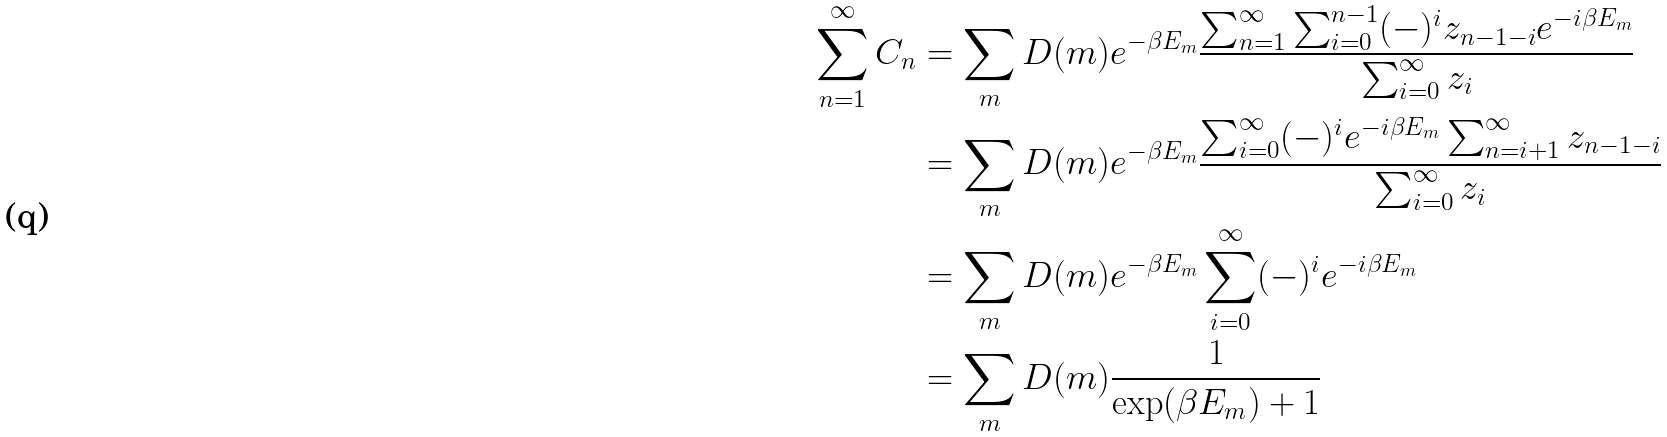Convert formula to latex. <formula><loc_0><loc_0><loc_500><loc_500>\sum _ { n = 1 } ^ { \infty } C _ { n } & = \sum _ { m } D ( m ) e ^ { - \beta E _ { m } } \frac { \sum _ { n = 1 } ^ { \infty } \sum _ { i = 0 } ^ { n - 1 } ( - ) ^ { i } z _ { n - 1 - i } e ^ { - i \beta E _ { m } } } { \sum _ { i = 0 } ^ { \infty } z _ { i } } \\ & = \sum _ { m } D ( m ) e ^ { - \beta E _ { m } } \frac { \sum _ { i = 0 } ^ { \infty } ( - ) ^ { i } e ^ { - i \beta E _ { m } } \sum _ { n = i + 1 } ^ { \infty } z _ { n - 1 - i } } { \sum _ { i = 0 } ^ { \infty } z _ { i } } \\ & = \sum _ { m } D ( m ) e ^ { - \beta E _ { m } } \sum _ { i = 0 } ^ { \infty } ( - ) ^ { i } e ^ { - i \beta E _ { m } } \\ & = \sum _ { m } D ( m ) \frac { 1 } { \exp ( \beta E _ { m } ) + 1 }</formula> 